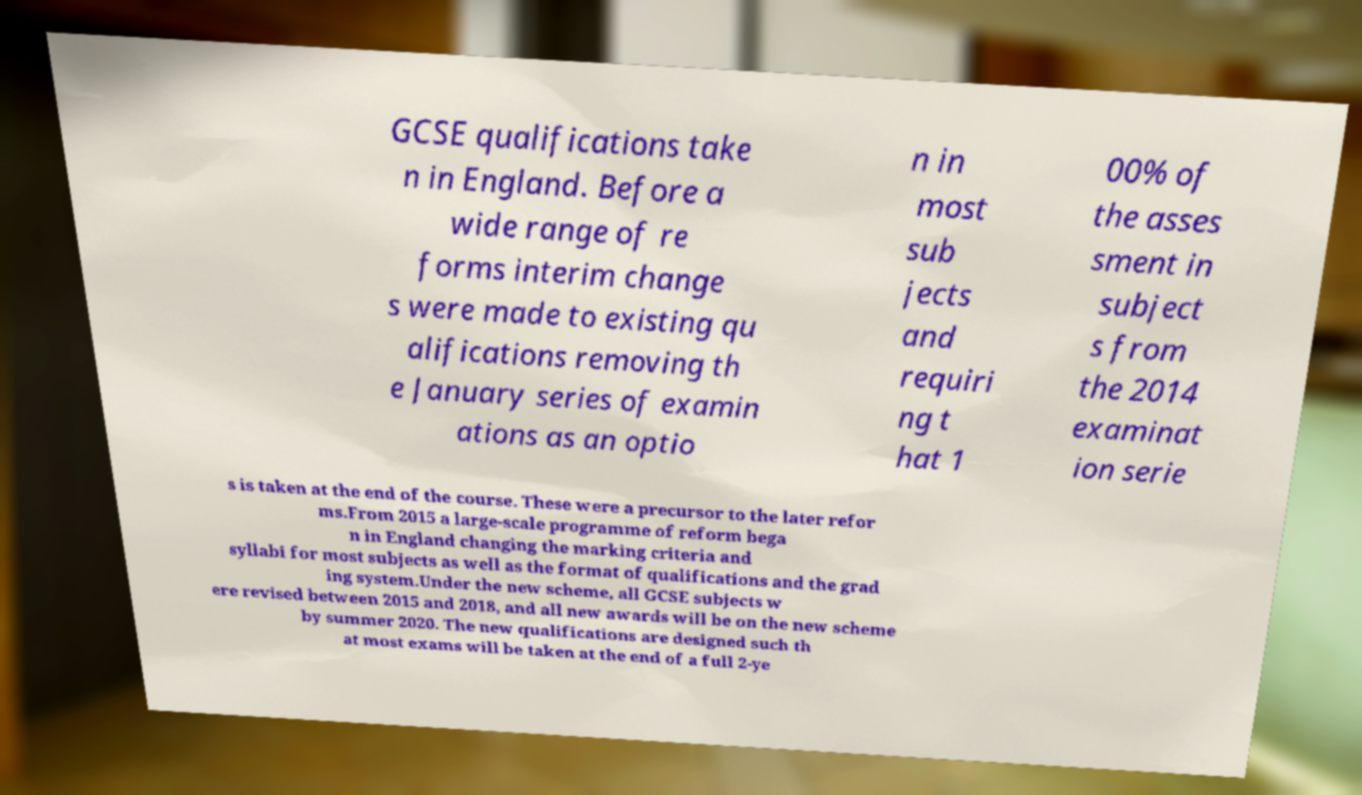Please read and relay the text visible in this image. What does it say? GCSE qualifications take n in England. Before a wide range of re forms interim change s were made to existing qu alifications removing th e January series of examin ations as an optio n in most sub jects and requiri ng t hat 1 00% of the asses sment in subject s from the 2014 examinat ion serie s is taken at the end of the course. These were a precursor to the later refor ms.From 2015 a large-scale programme of reform bega n in England changing the marking criteria and syllabi for most subjects as well as the format of qualifications and the grad ing system.Under the new scheme, all GCSE subjects w ere revised between 2015 and 2018, and all new awards will be on the new scheme by summer 2020. The new qualifications are designed such th at most exams will be taken at the end of a full 2-ye 